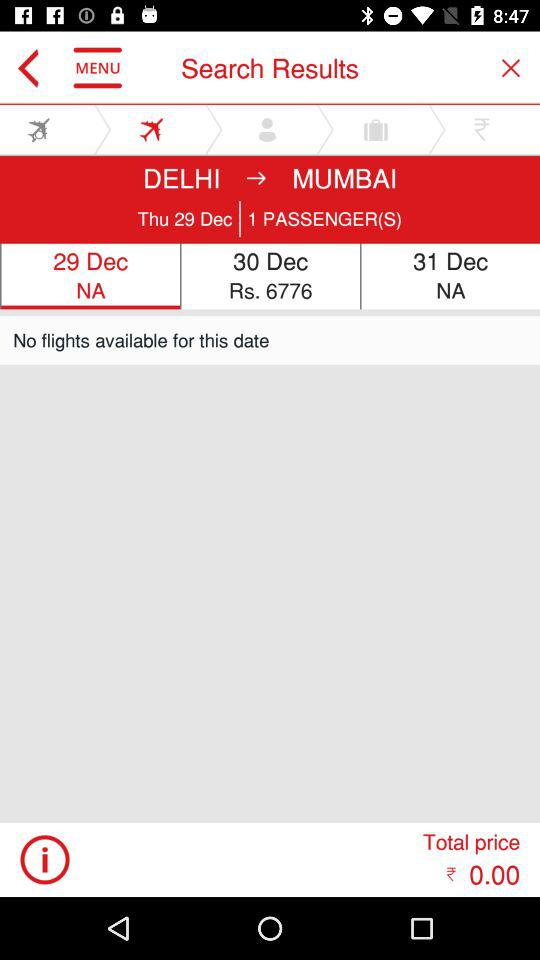What date is selected? The selected date is December 29. 